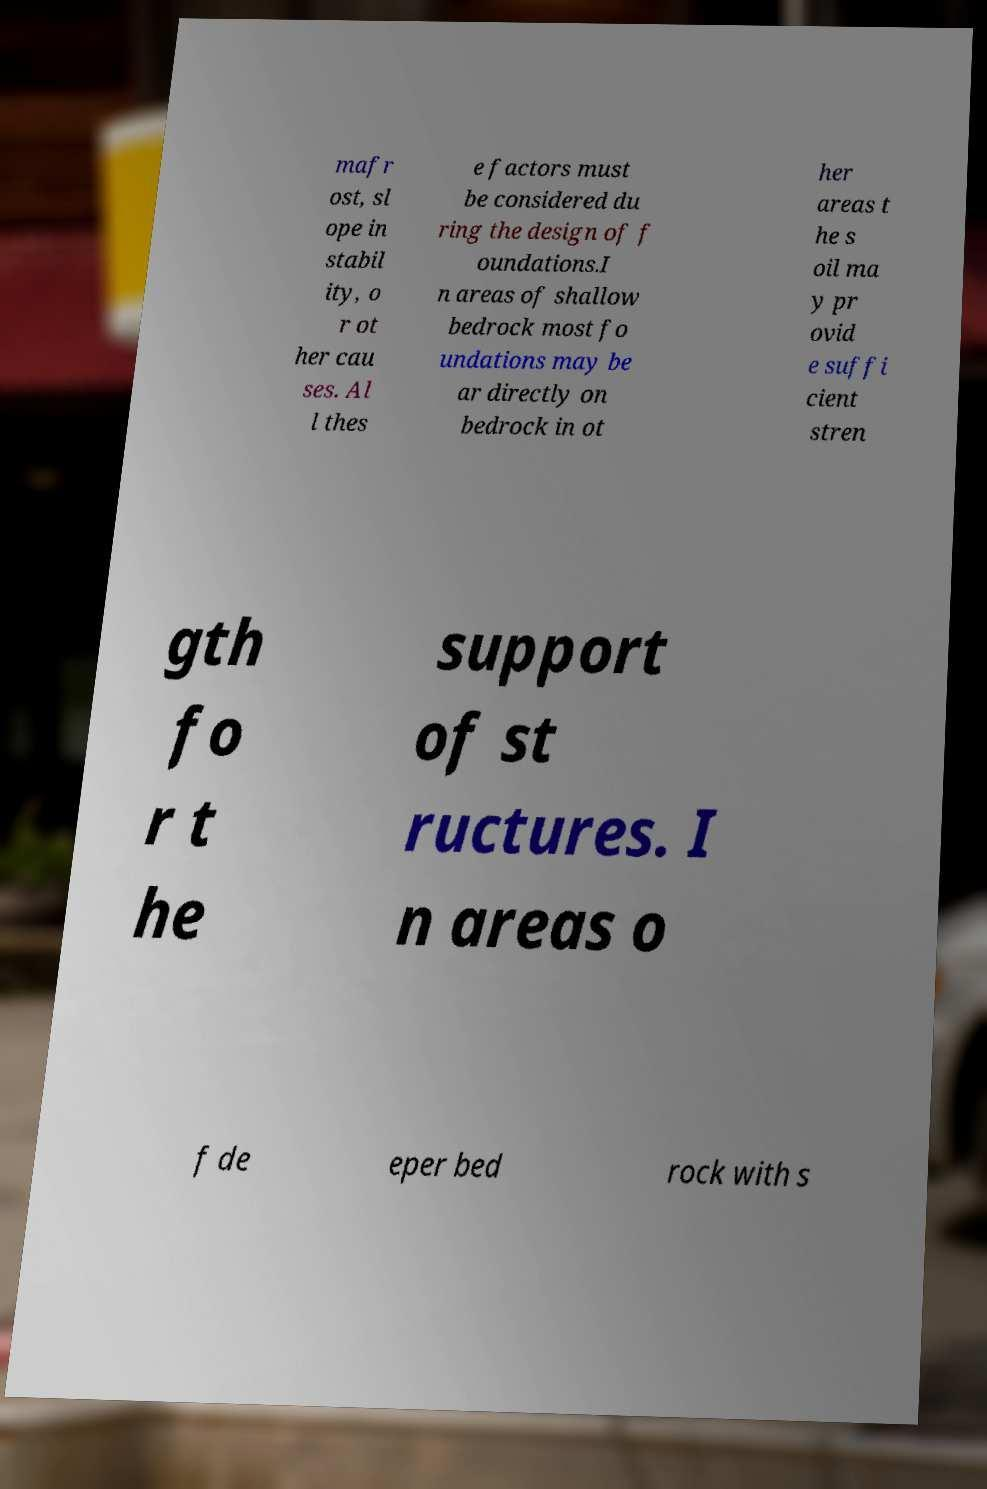Can you read and provide the text displayed in the image?This photo seems to have some interesting text. Can you extract and type it out for me? mafr ost, sl ope in stabil ity, o r ot her cau ses. Al l thes e factors must be considered du ring the design of f oundations.I n areas of shallow bedrock most fo undations may be ar directly on bedrock in ot her areas t he s oil ma y pr ovid e suffi cient stren gth fo r t he support of st ructures. I n areas o f de eper bed rock with s 